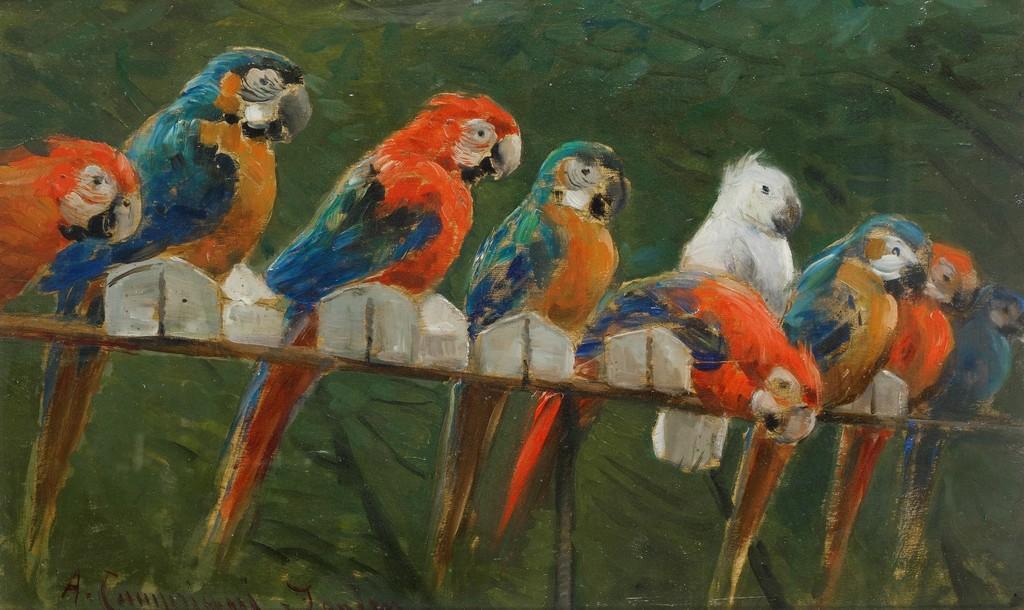Can you describe this image briefly? In this picture we can see the painting of some parrots on a wooden branch and trees. We can see some text in the bottom left. 